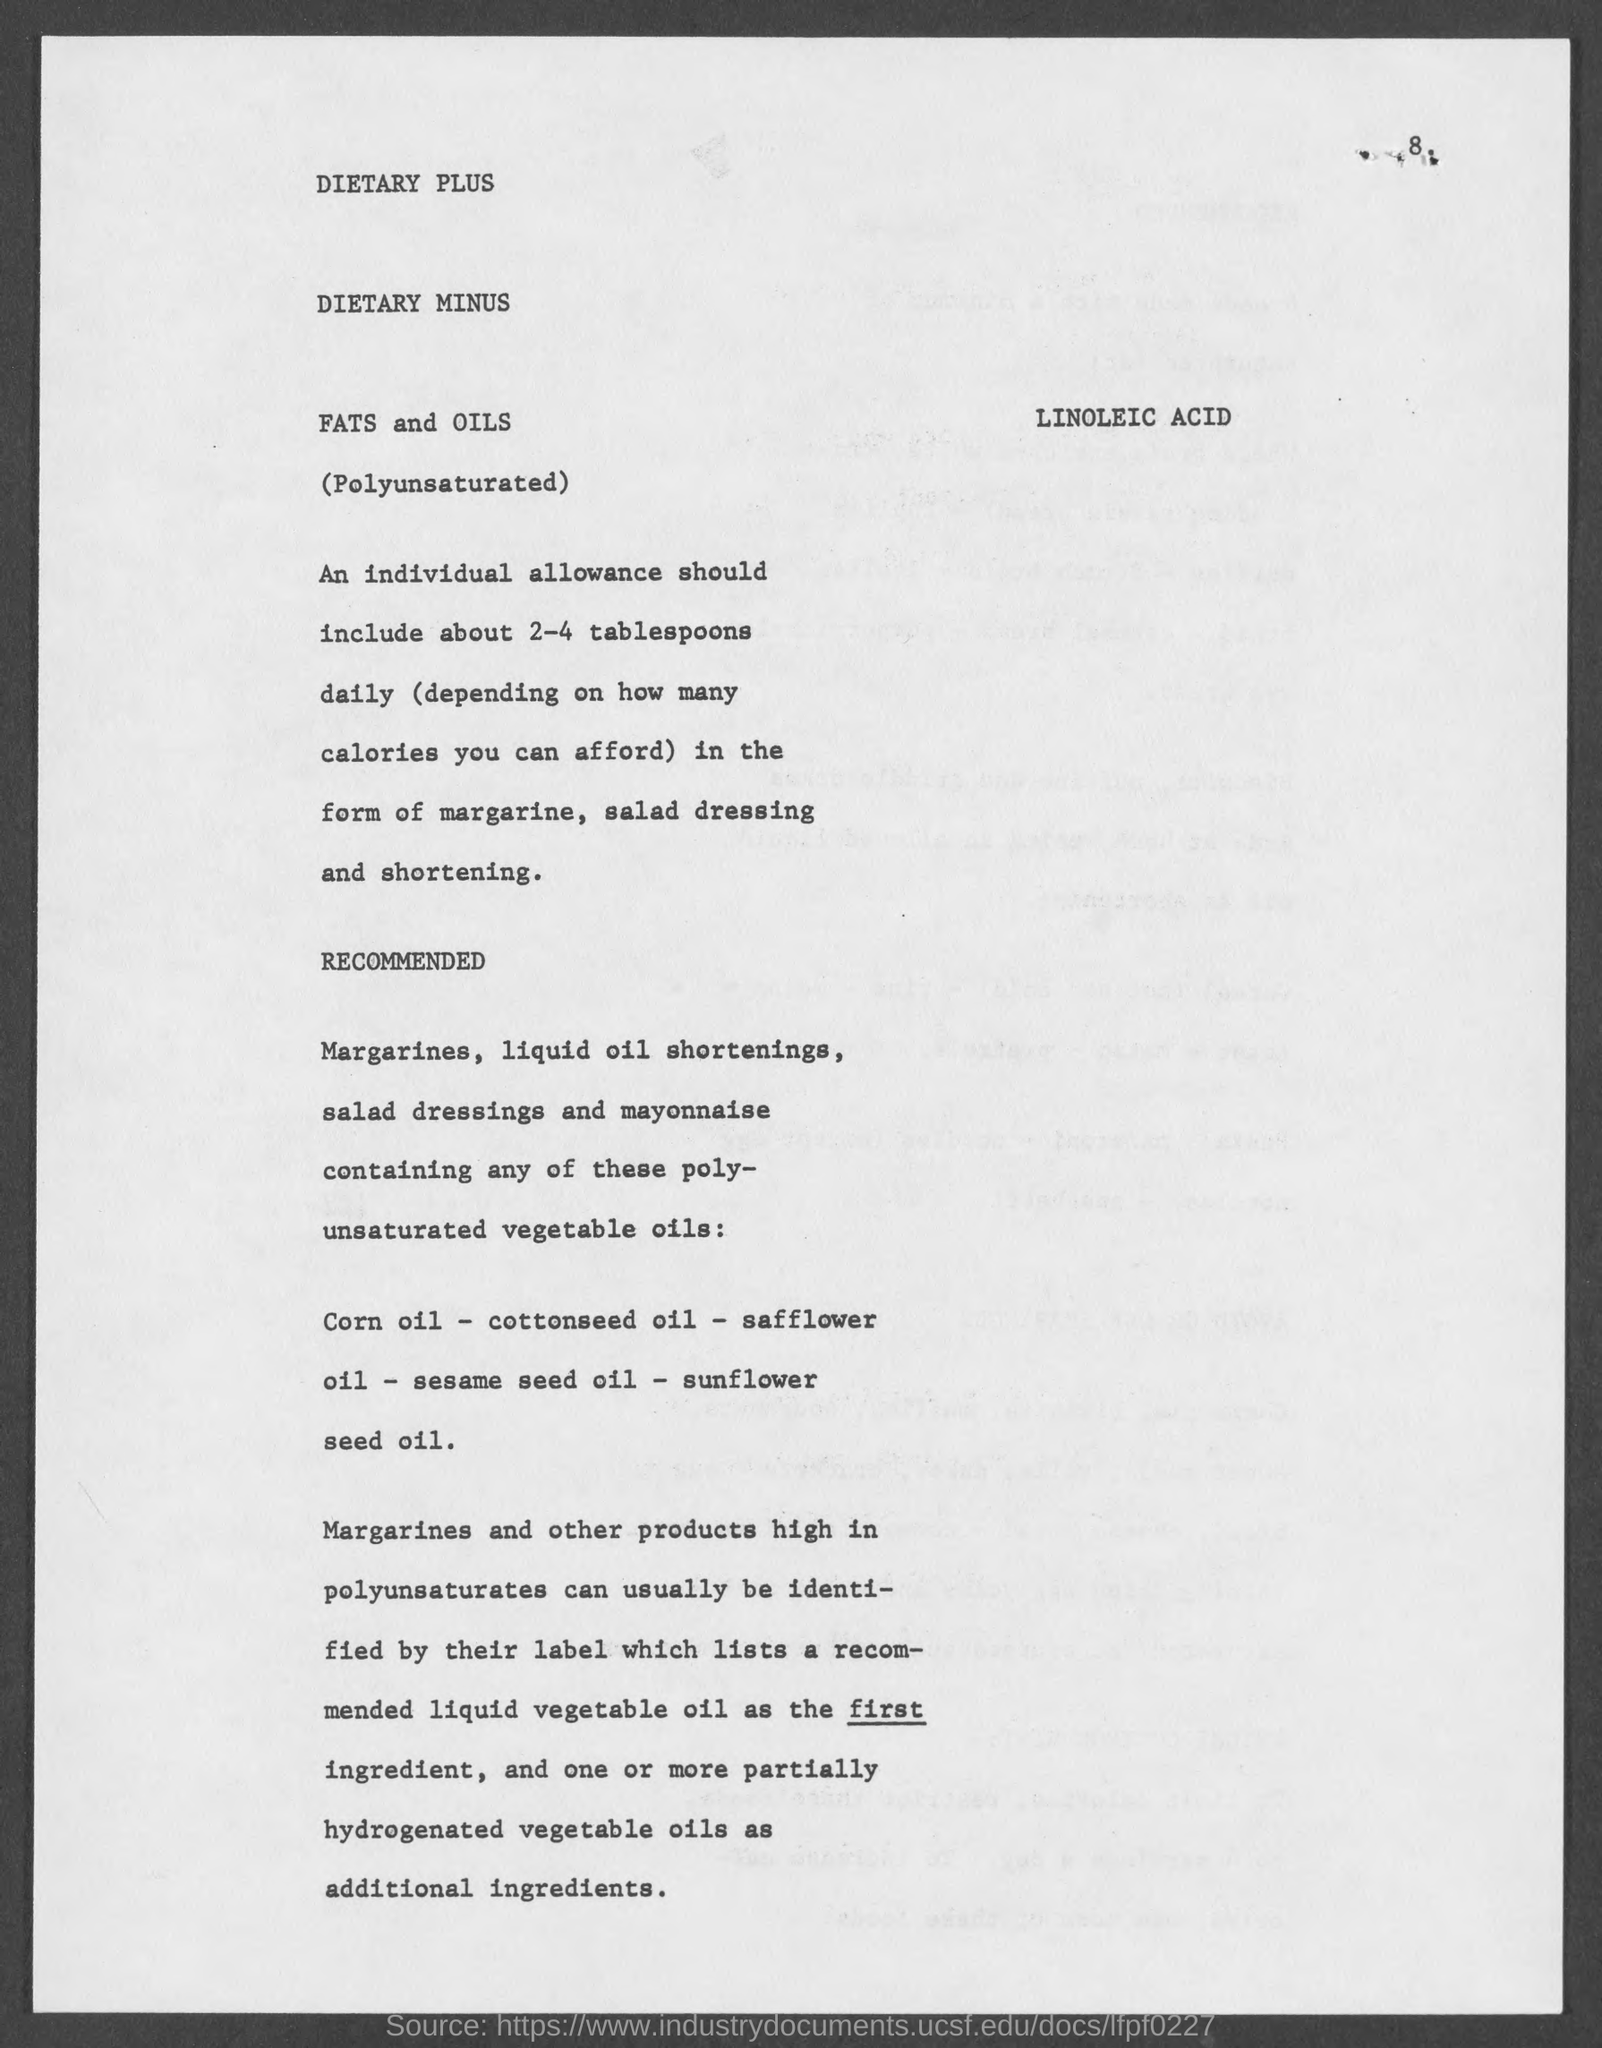How many tablespoons in the form of margarine,salad dressing and shortening should an individual should take ?
Give a very brief answer. 2-4. 